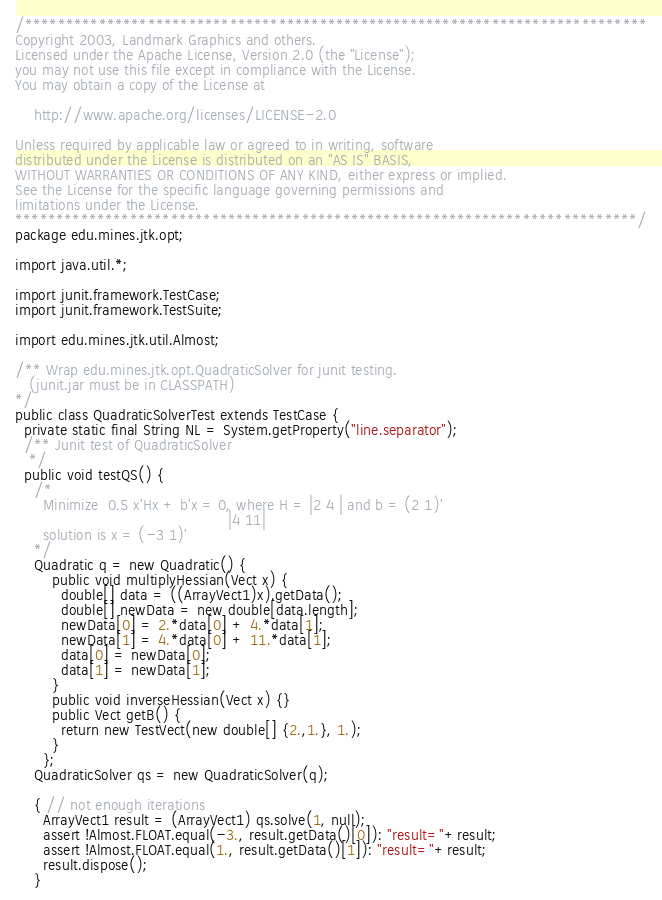<code> <loc_0><loc_0><loc_500><loc_500><_Java_>/****************************************************************************
Copyright 2003, Landmark Graphics and others.
Licensed under the Apache License, Version 2.0 (the "License");
you may not use this file except in compliance with the License.
You may obtain a copy of the License at

    http://www.apache.org/licenses/LICENSE-2.0

Unless required by applicable law or agreed to in writing, software
distributed under the License is distributed on an "AS IS" BASIS,
WITHOUT WARRANTIES OR CONDITIONS OF ANY KIND, either express or implied.
See the License for the specific language governing permissions and
limitations under the License.
****************************************************************************/
package edu.mines.jtk.opt;

import java.util.*;

import junit.framework.TestCase;
import junit.framework.TestSuite;

import edu.mines.jtk.util.Almost;

/** Wrap edu.mines.jtk.opt.QuadraticSolver for junit testing.
   (junit.jar must be in CLASSPATH)
*/
public class QuadraticSolverTest extends TestCase {
  private static final String NL = System.getProperty("line.separator");
  /** Junit test of QuadraticSolver
   */
  public void testQS() {
    /*
      Minimize  0.5 x'Hx + b'x = 0, where H = |2 4 | and b = (2 1)'
                                              |4 11|
      solution is x = (-3 1)'
    */
    Quadratic q = new Quadratic() {
        public void multiplyHessian(Vect x) {
          double[] data = ((ArrayVect1)x).getData();
          double[] newData = new double[data.length];
          newData[0] = 2.*data[0] + 4.*data[1];
          newData[1] = 4.*data[0] + 11.*data[1];
          data[0] = newData[0];
          data[1] = newData[1];
        }
        public void inverseHessian(Vect x) {}
        public Vect getB() {
          return new TestVect(new double[] {2.,1.}, 1.);
        }
      };
    QuadraticSolver qs = new QuadraticSolver(q);

    { // not enough iterations
      ArrayVect1 result = (ArrayVect1) qs.solve(1, null);
      assert !Almost.FLOAT.equal(-3., result.getData()[0]): "result="+result;
      assert !Almost.FLOAT.equal(1., result.getData()[1]): "result="+result;
      result.dispose();
    }</code> 